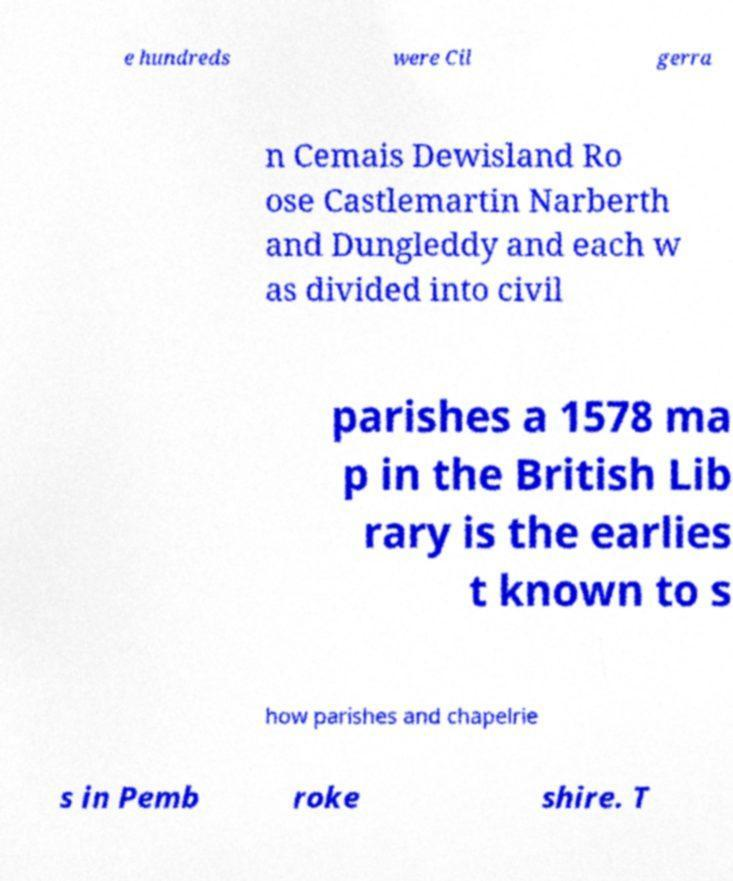I need the written content from this picture converted into text. Can you do that? e hundreds were Cil gerra n Cemais Dewisland Ro ose Castlemartin Narberth and Dungleddy and each w as divided into civil parishes a 1578 ma p in the British Lib rary is the earlies t known to s how parishes and chapelrie s in Pemb roke shire. T 